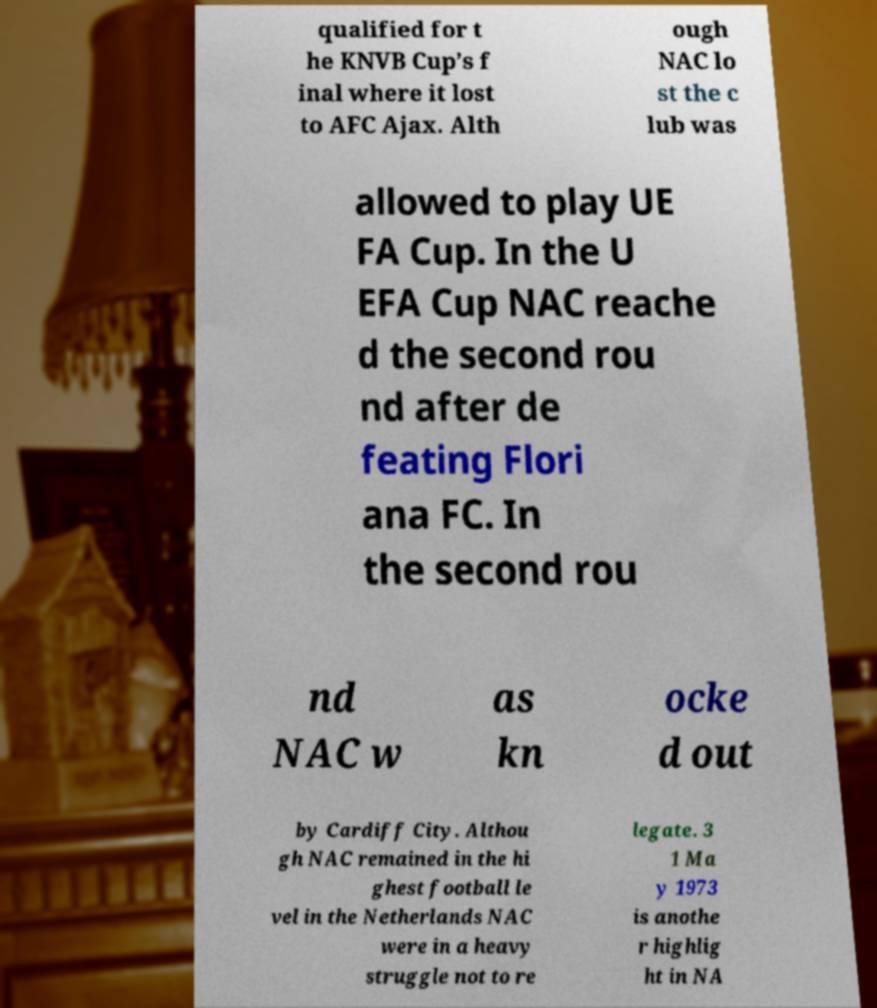Can you accurately transcribe the text from the provided image for me? qualified for t he KNVB Cup’s f inal where it lost to AFC Ajax. Alth ough NAC lo st the c lub was allowed to play UE FA Cup. In the U EFA Cup NAC reache d the second rou nd after de feating Flori ana FC. In the second rou nd NAC w as kn ocke d out by Cardiff City. Althou gh NAC remained in the hi ghest football le vel in the Netherlands NAC were in a heavy struggle not to re legate. 3 1 Ma y 1973 is anothe r highlig ht in NA 